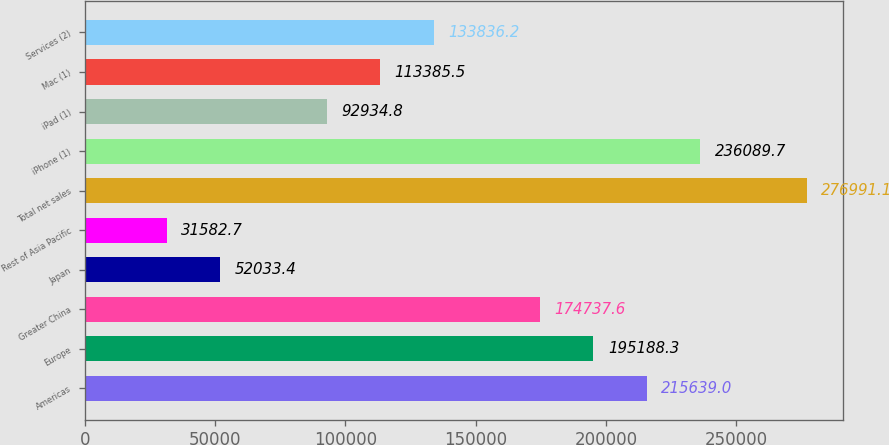Convert chart. <chart><loc_0><loc_0><loc_500><loc_500><bar_chart><fcel>Americas<fcel>Europe<fcel>Greater China<fcel>Japan<fcel>Rest of Asia Pacific<fcel>Total net sales<fcel>iPhone (1)<fcel>iPad (1)<fcel>Mac (1)<fcel>Services (2)<nl><fcel>215639<fcel>195188<fcel>174738<fcel>52033.4<fcel>31582.7<fcel>276991<fcel>236090<fcel>92934.8<fcel>113386<fcel>133836<nl></chart> 